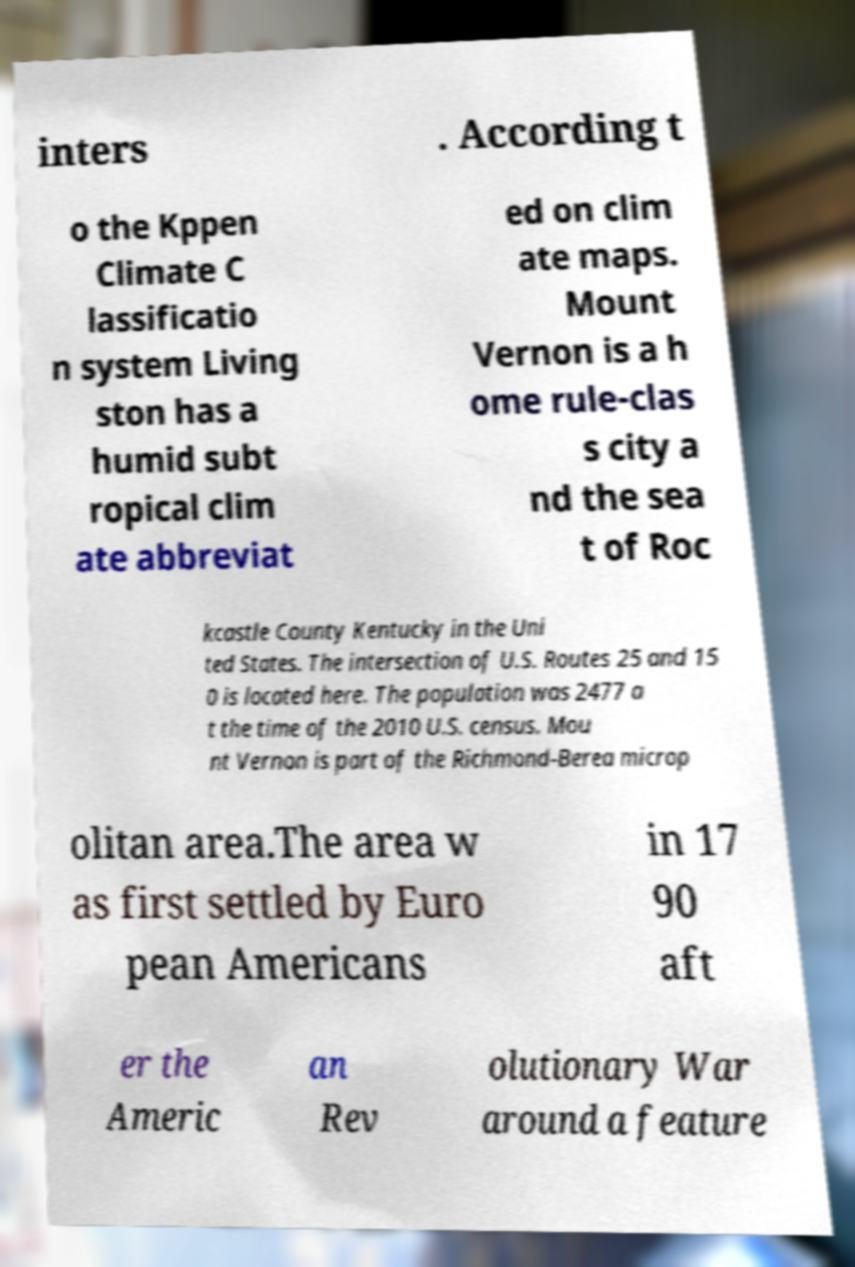Could you extract and type out the text from this image? inters . According t o the Kppen Climate C lassificatio n system Living ston has a humid subt ropical clim ate abbreviat ed on clim ate maps. Mount Vernon is a h ome rule-clas s city a nd the sea t of Roc kcastle County Kentucky in the Uni ted States. The intersection of U.S. Routes 25 and 15 0 is located here. The population was 2477 a t the time of the 2010 U.S. census. Mou nt Vernon is part of the Richmond-Berea microp olitan area.The area w as first settled by Euro pean Americans in 17 90 aft er the Americ an Rev olutionary War around a feature 